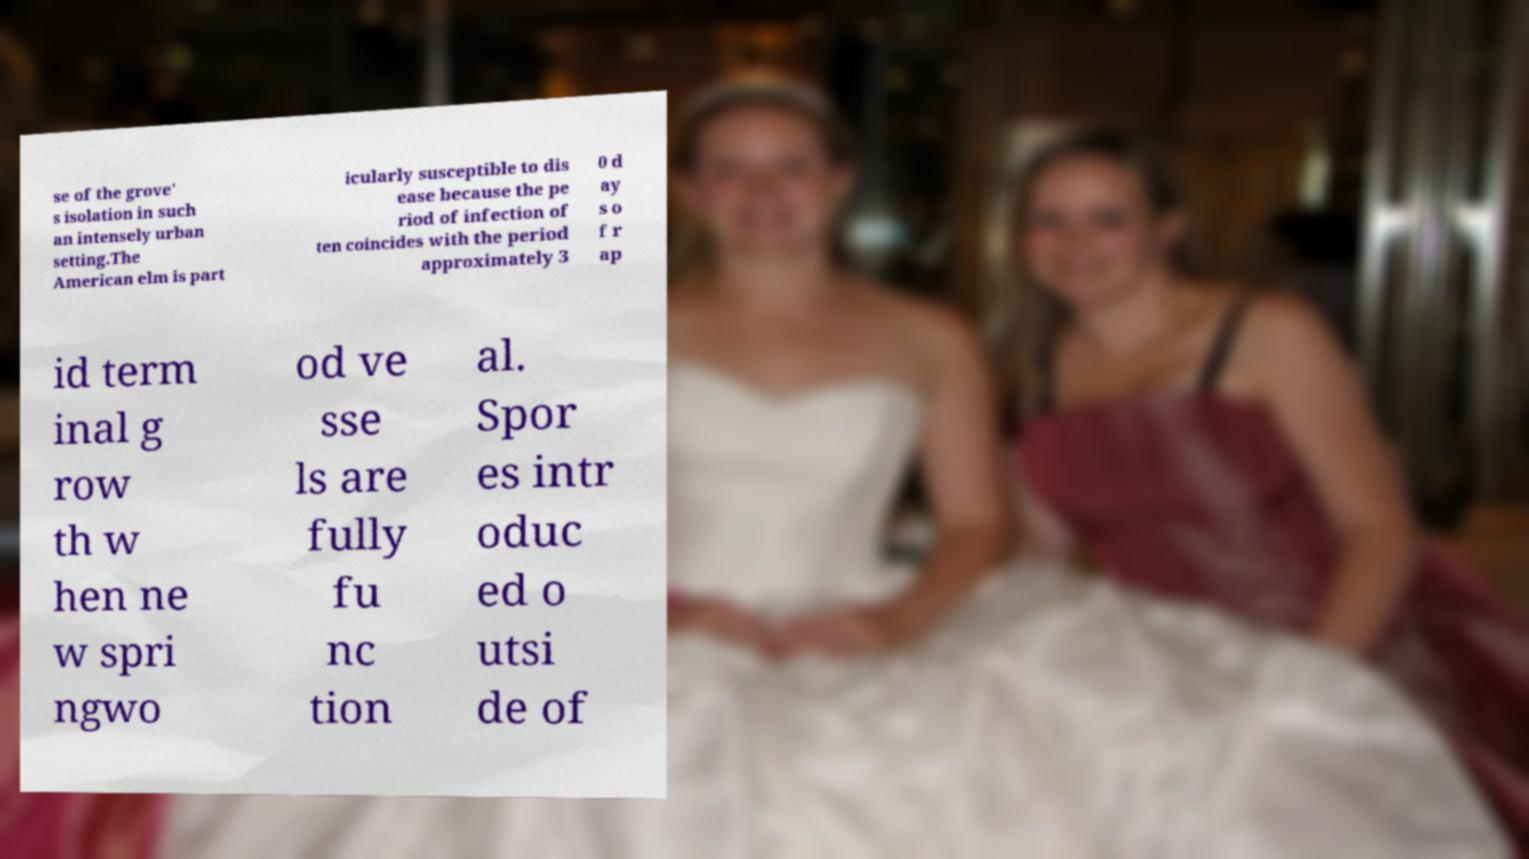Can you accurately transcribe the text from the provided image for me? se of the grove' s isolation in such an intensely urban setting.The American elm is part icularly susceptible to dis ease because the pe riod of infection of ten coincides with the period approximately 3 0 d ay s o f r ap id term inal g row th w hen ne w spri ngwo od ve sse ls are fully fu nc tion al. Spor es intr oduc ed o utsi de of 